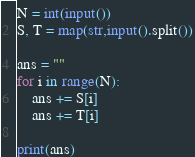Convert code to text. <code><loc_0><loc_0><loc_500><loc_500><_Python_>N = int(input())
S, T = map(str,input().split())

ans = ""
for i in range(N):
    ans += S[i]
    ans += T[i]
    
print(ans)</code> 